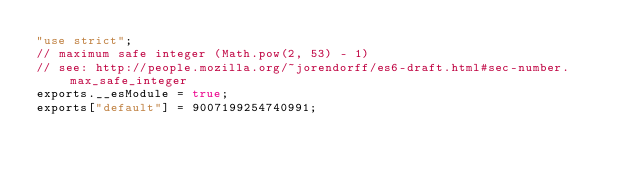<code> <loc_0><loc_0><loc_500><loc_500><_JavaScript_>"use strict";
// maximum safe integer (Math.pow(2, 53) - 1)
// see: http://people.mozilla.org/~jorendorff/es6-draft.html#sec-number.max_safe_integer
exports.__esModule = true;
exports["default"] = 9007199254740991;
</code> 